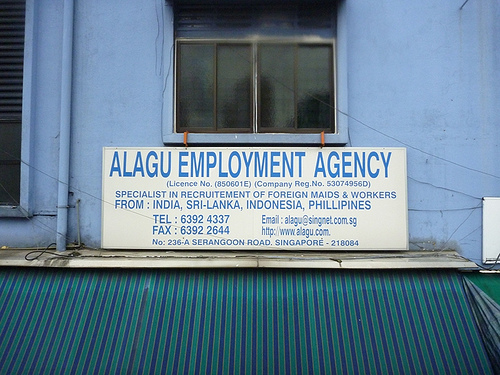<image>
Can you confirm if the sign is in front of the wall? Yes. The sign is positioned in front of the wall, appearing closer to the camera viewpoint. 